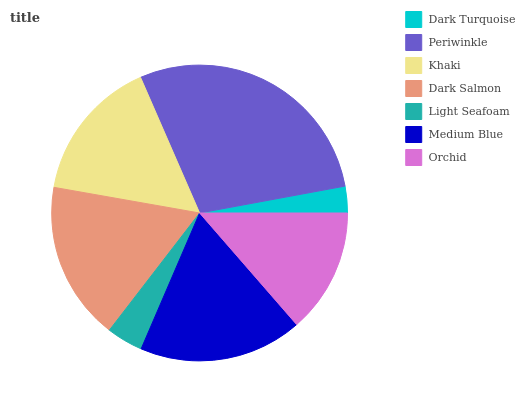Is Dark Turquoise the minimum?
Answer yes or no. Yes. Is Periwinkle the maximum?
Answer yes or no. Yes. Is Khaki the minimum?
Answer yes or no. No. Is Khaki the maximum?
Answer yes or no. No. Is Periwinkle greater than Khaki?
Answer yes or no. Yes. Is Khaki less than Periwinkle?
Answer yes or no. Yes. Is Khaki greater than Periwinkle?
Answer yes or no. No. Is Periwinkle less than Khaki?
Answer yes or no. No. Is Khaki the high median?
Answer yes or no. Yes. Is Khaki the low median?
Answer yes or no. Yes. Is Dark Turquoise the high median?
Answer yes or no. No. Is Orchid the low median?
Answer yes or no. No. 